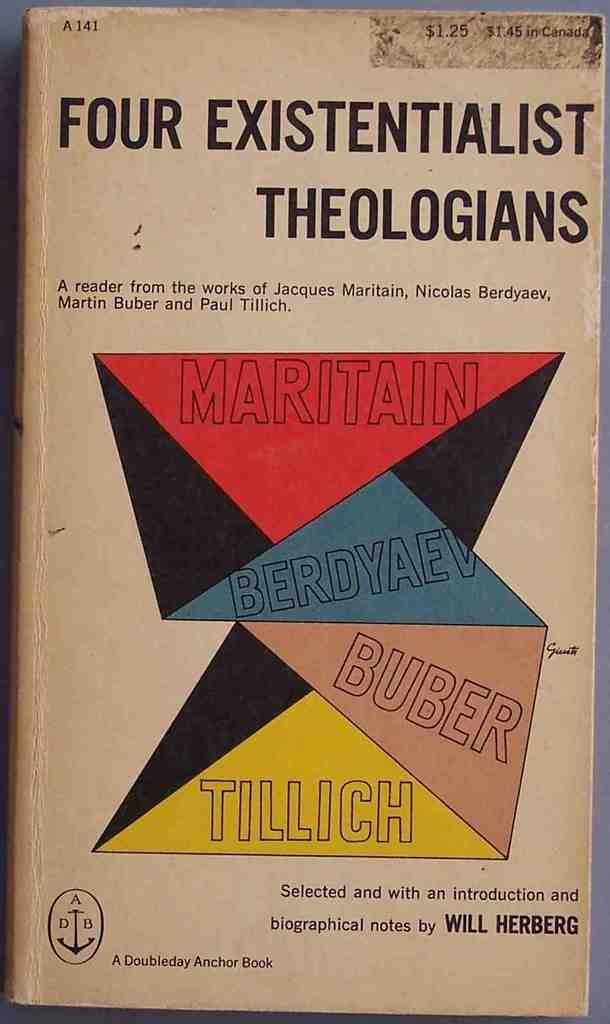<image>
Describe the image concisely. A book of four existentialist Theologians published by A Doubleday Anchor book. 